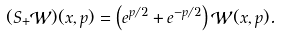Convert formula to latex. <formula><loc_0><loc_0><loc_500><loc_500>( S _ { + } { \mathcal { W } } ) ( x , p ) = \left ( e ^ { p / 2 } + e ^ { - p / 2 } \right ) { \mathcal { W } } ( x , p ) .</formula> 